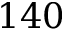<formula> <loc_0><loc_0><loc_500><loc_500>1 4 0</formula> 